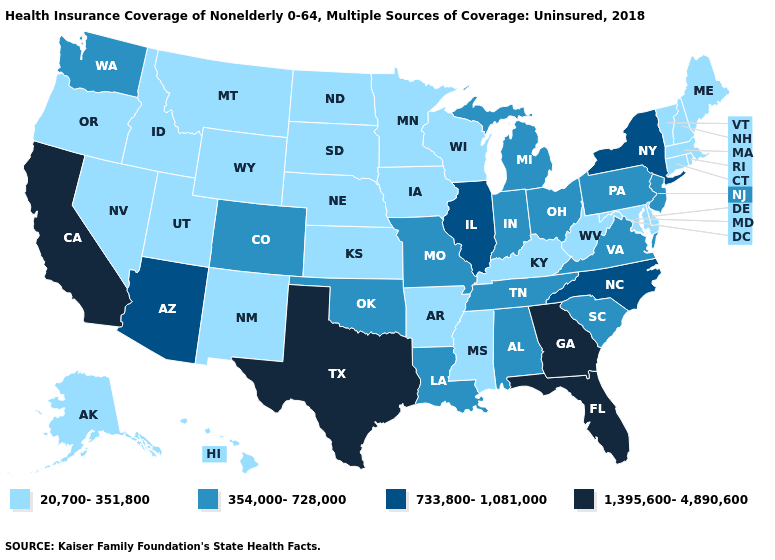Name the states that have a value in the range 733,800-1,081,000?
Keep it brief. Arizona, Illinois, New York, North Carolina. Which states have the lowest value in the USA?
Quick response, please. Alaska, Arkansas, Connecticut, Delaware, Hawaii, Idaho, Iowa, Kansas, Kentucky, Maine, Maryland, Massachusetts, Minnesota, Mississippi, Montana, Nebraska, Nevada, New Hampshire, New Mexico, North Dakota, Oregon, Rhode Island, South Dakota, Utah, Vermont, West Virginia, Wisconsin, Wyoming. Does New York have the lowest value in the Northeast?
Short answer required. No. What is the highest value in the West ?
Be succinct. 1,395,600-4,890,600. Does Florida have the highest value in the USA?
Keep it brief. Yes. Among the states that border Illinois , does Missouri have the lowest value?
Keep it brief. No. Among the states that border Texas , does Arkansas have the highest value?
Keep it brief. No. Name the states that have a value in the range 733,800-1,081,000?
Quick response, please. Arizona, Illinois, New York, North Carolina. What is the value of Kansas?
Short answer required. 20,700-351,800. Among the states that border Texas , does New Mexico have the highest value?
Write a very short answer. No. Name the states that have a value in the range 1,395,600-4,890,600?
Answer briefly. California, Florida, Georgia, Texas. Among the states that border North Carolina , which have the lowest value?
Answer briefly. South Carolina, Tennessee, Virginia. Does Illinois have the highest value in the MidWest?
Short answer required. Yes. Name the states that have a value in the range 20,700-351,800?
Short answer required. Alaska, Arkansas, Connecticut, Delaware, Hawaii, Idaho, Iowa, Kansas, Kentucky, Maine, Maryland, Massachusetts, Minnesota, Mississippi, Montana, Nebraska, Nevada, New Hampshire, New Mexico, North Dakota, Oregon, Rhode Island, South Dakota, Utah, Vermont, West Virginia, Wisconsin, Wyoming. What is the value of South Carolina?
Short answer required. 354,000-728,000. 